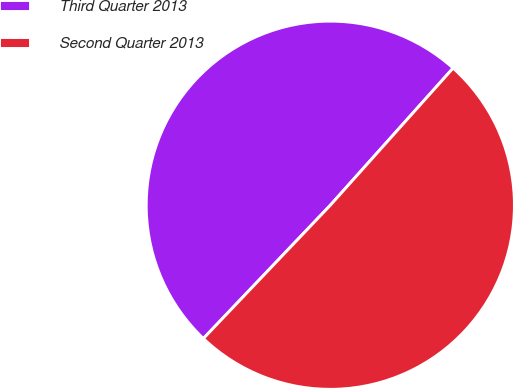Convert chart to OTSL. <chart><loc_0><loc_0><loc_500><loc_500><pie_chart><fcel>Third Quarter 2013<fcel>Second Quarter 2013<nl><fcel>49.51%<fcel>50.49%<nl></chart> 